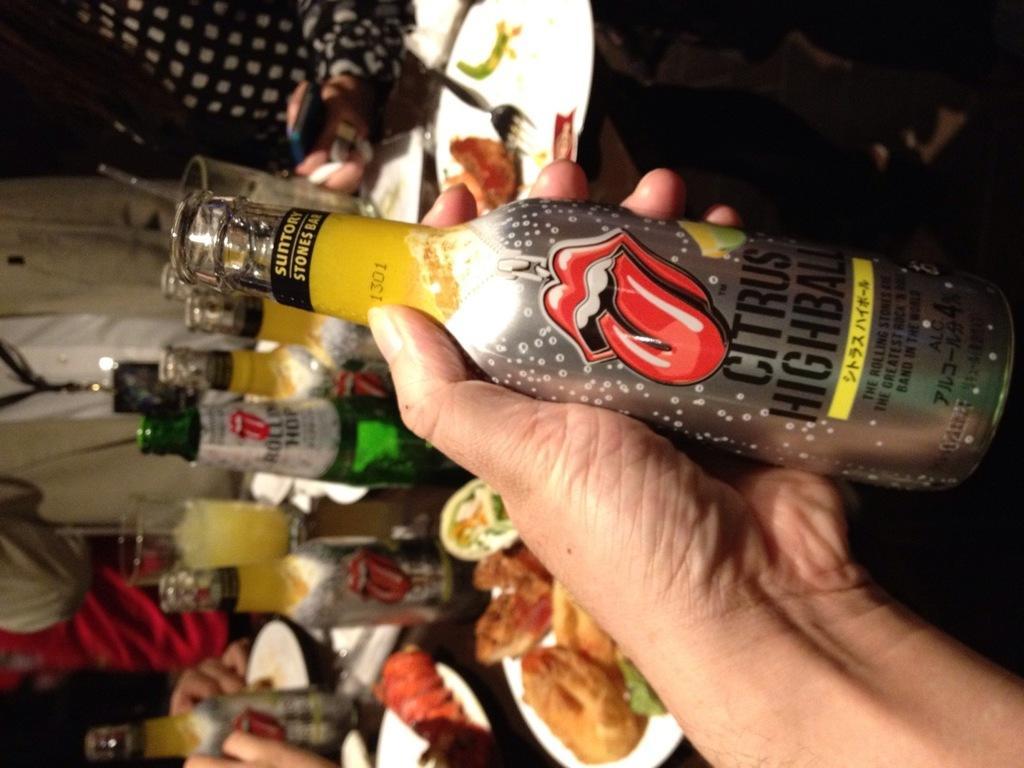Describe this image in one or two sentences. In the image the person is holding a bottle on which it is labelled as 'CITRUS'. In background we can also see few bottles on table and a fork. 